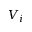Convert formula to latex. <formula><loc_0><loc_0><loc_500><loc_500>V _ { i }</formula> 